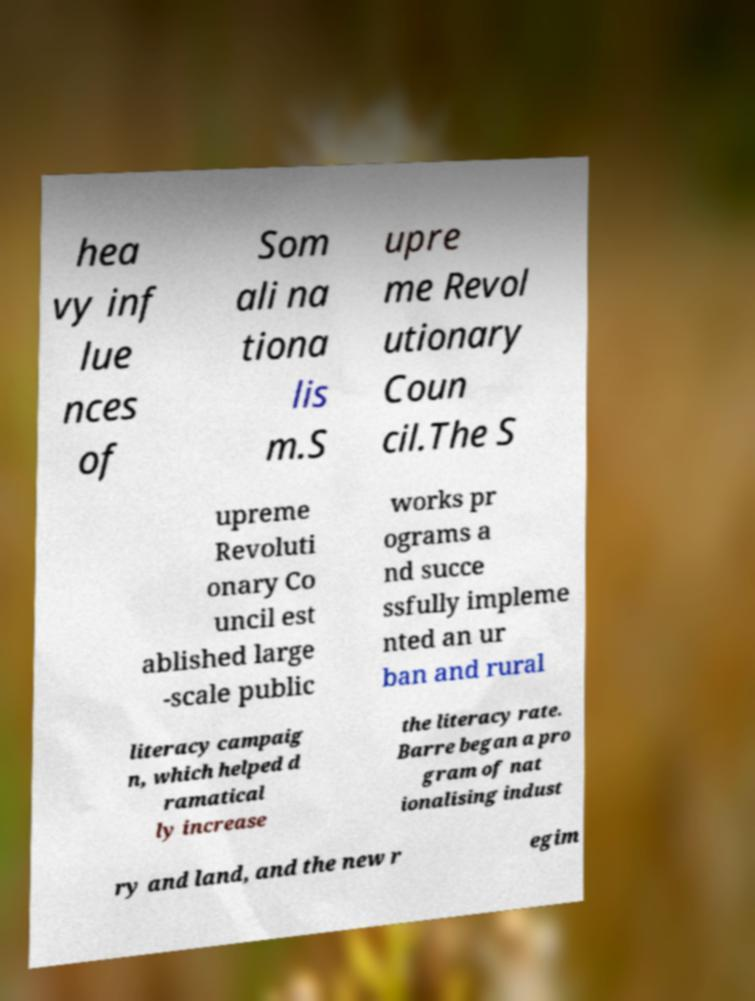For documentation purposes, I need the text within this image transcribed. Could you provide that? hea vy inf lue nces of Som ali na tiona lis m.S upre me Revol utionary Coun cil.The S upreme Revoluti onary Co uncil est ablished large -scale public works pr ograms a nd succe ssfully impleme nted an ur ban and rural literacy campaig n, which helped d ramatical ly increase the literacy rate. Barre began a pro gram of nat ionalising indust ry and land, and the new r egim 